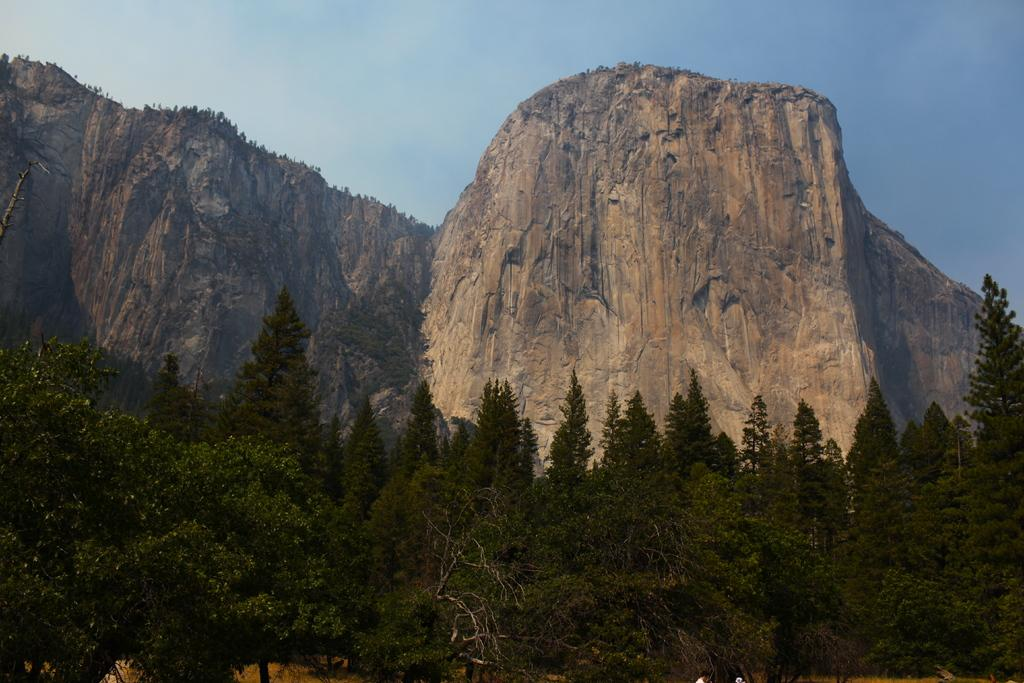What type of vegetation is visible in the front of the image? There are trees in the front of the image. What type of natural formation can be seen in the background of the image? There are mountains in the background of the image. What is visible above the mountains in the image? The sky is visible above the mountains. What type of jar can be seen in the sky above the mountains? There is no jar present in the sky above the mountains; only the sky is visible. How does the air in the image affect the mind of the viewer? The image does not provide information about the air or its effect on the viewer's mind. 